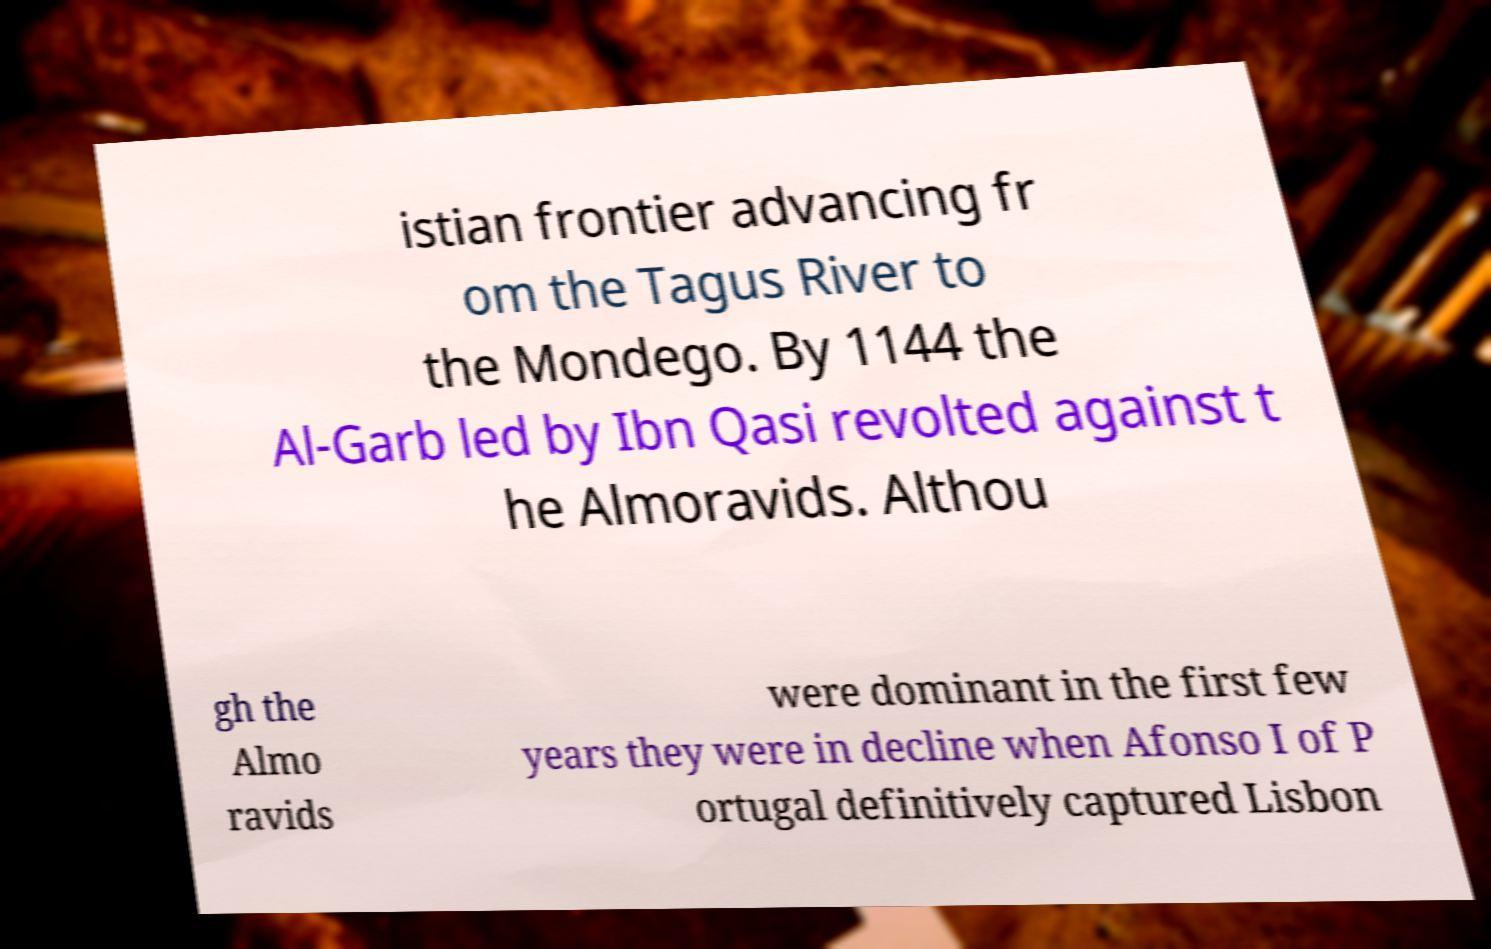There's text embedded in this image that I need extracted. Can you transcribe it verbatim? istian frontier advancing fr om the Tagus River to the Mondego. By 1144 the Al-Garb led by Ibn Qasi revolted against t he Almoravids. Althou gh the Almo ravids were dominant in the first few years they were in decline when Afonso I of P ortugal definitively captured Lisbon 